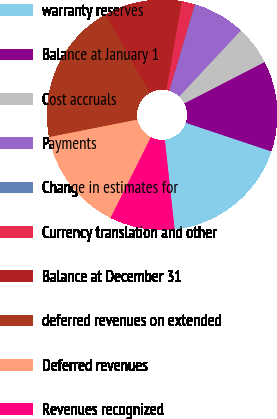Convert chart. <chart><loc_0><loc_0><loc_500><loc_500><pie_chart><fcel>warranty reserves<fcel>Balance at January 1<fcel>Cost accruals<fcel>Payments<fcel>Change in estimates for<fcel>Currency translation and other<fcel>Balance at December 31<fcel>deferred revenues on extended<fcel>Deferred revenues<fcel>Revenues recognized<nl><fcel>18.13%<fcel>12.71%<fcel>5.48%<fcel>7.29%<fcel>0.07%<fcel>1.87%<fcel>10.9%<fcel>19.93%<fcel>14.52%<fcel>9.1%<nl></chart> 